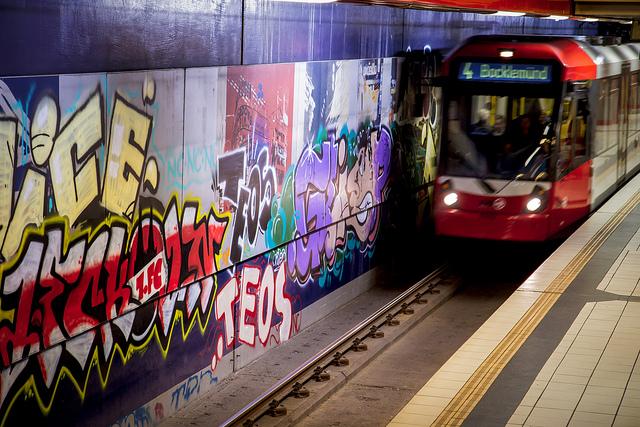What is the train's destination?
Short answer required. Bocklemund. Is there graffiti on the wall?
Quick response, please. Yes. What are some of the words that are written on the wall?
Concise answer only. Teos. 